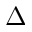Convert formula to latex. <formula><loc_0><loc_0><loc_500><loc_500>\Delta</formula> 